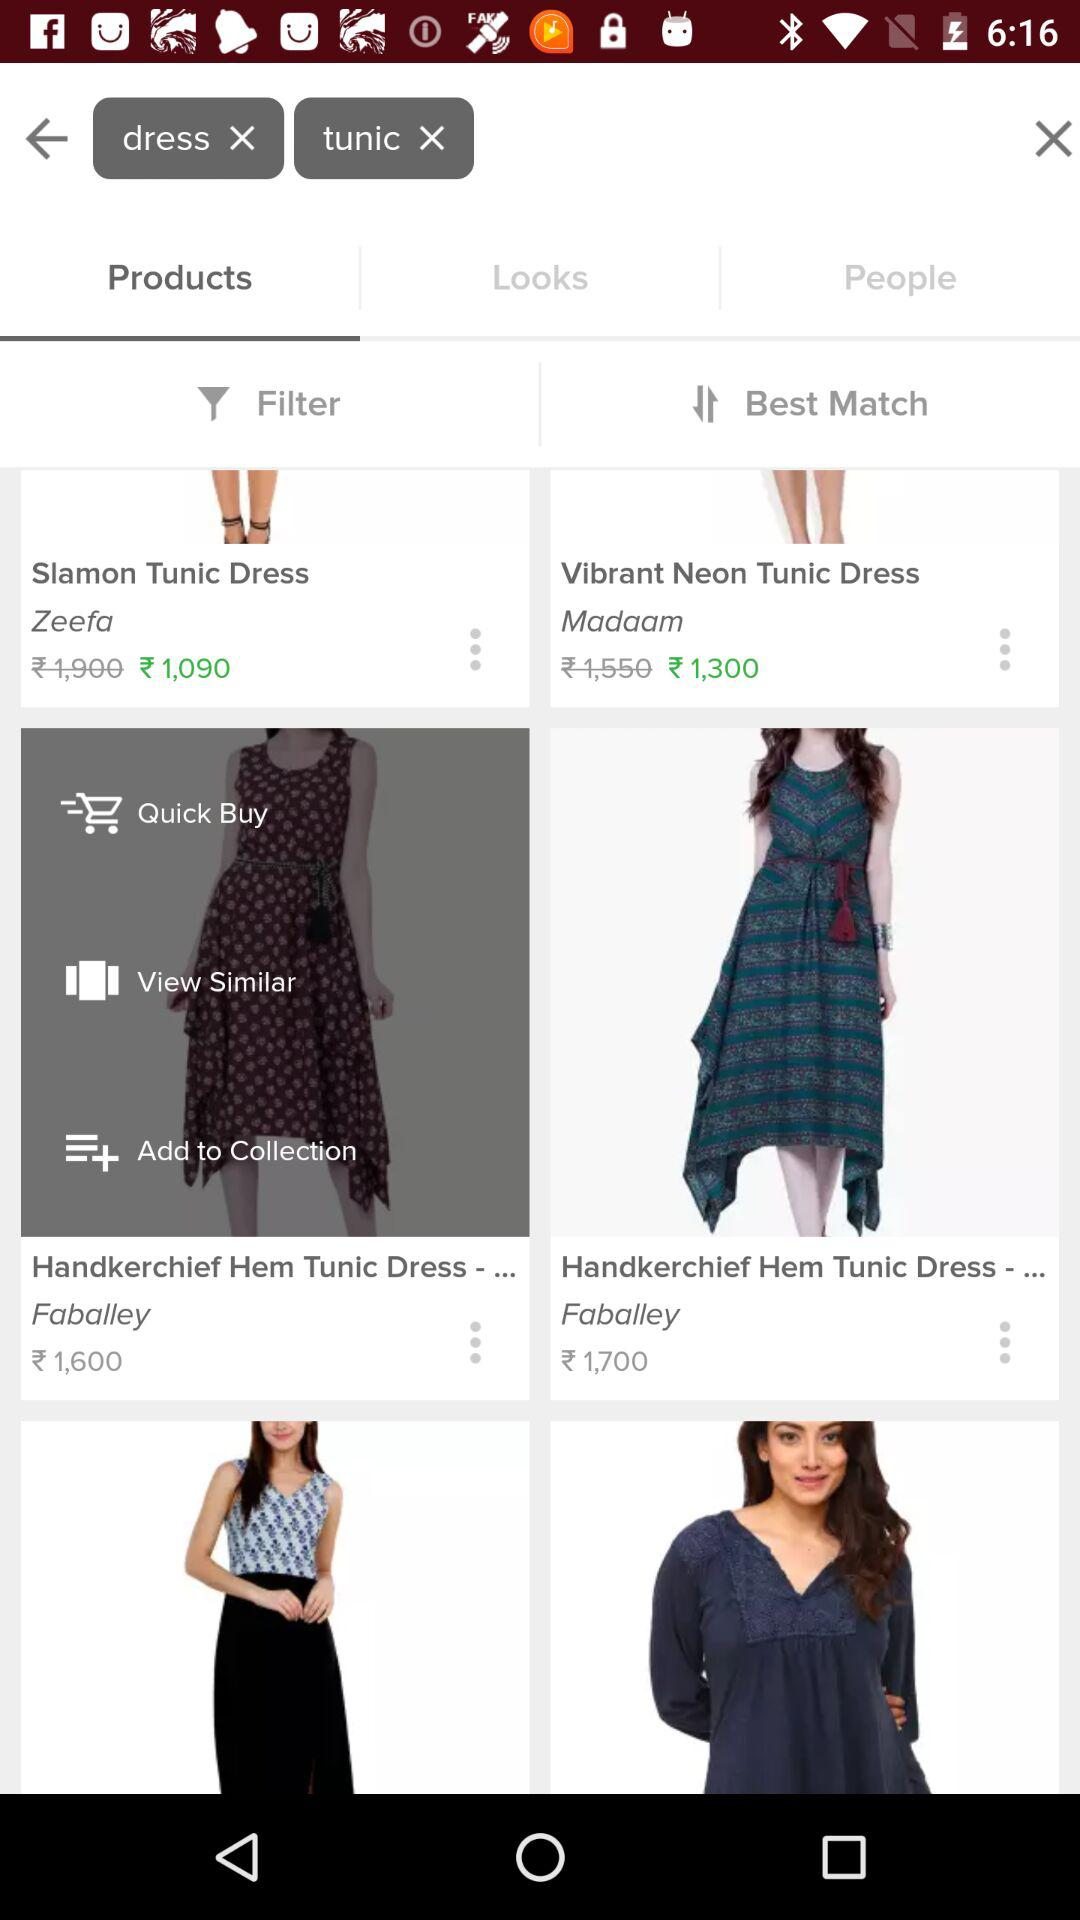Which tab has been selected? The selected tab is "Products". 